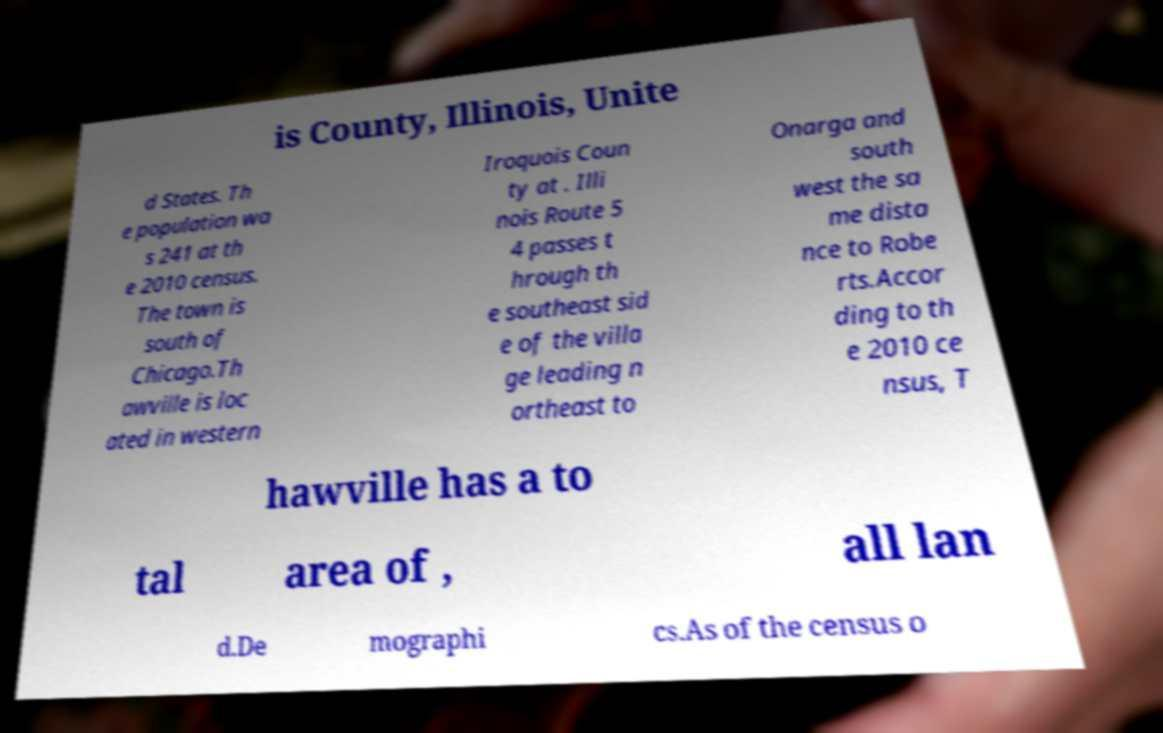There's text embedded in this image that I need extracted. Can you transcribe it verbatim? is County, Illinois, Unite d States. Th e population wa s 241 at th e 2010 census. The town is south of Chicago.Th awville is loc ated in western Iroquois Coun ty at . Illi nois Route 5 4 passes t hrough th e southeast sid e of the villa ge leading n ortheast to Onarga and south west the sa me dista nce to Robe rts.Accor ding to th e 2010 ce nsus, T hawville has a to tal area of , all lan d.De mographi cs.As of the census o 